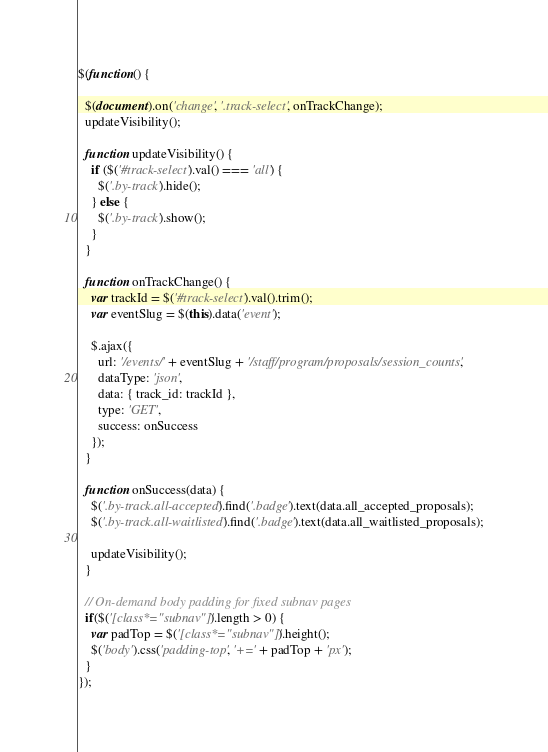<code> <loc_0><loc_0><loc_500><loc_500><_JavaScript_>$(function() {

  $(document).on('change', '.track-select', onTrackChange);
  updateVisibility();

  function updateVisibility() {
    if ($('#track-select').val() === 'all') {
      $('.by-track').hide();
    } else {
      $('.by-track').show();
    }
  }

  function onTrackChange() {
    var trackId = $('#track-select').val().trim();
    var eventSlug = $(this).data('event');

    $.ajax({
      url: '/events/' + eventSlug + '/staff/program/proposals/session_counts',
      dataType: 'json',
      data: { track_id: trackId },
      type: 'GET',
      success: onSuccess
    });
  }

  function onSuccess(data) {
    $('.by-track.all-accepted').find('.badge').text(data.all_accepted_proposals);
    $('.by-track.all-waitlisted').find('.badge').text(data.all_waitlisted_proposals);

    updateVisibility();
  }

  // On-demand body padding for fixed subnav pages
  if($('[class*="subnav"]').length > 0) {
    var padTop = $('[class*="subnav"]').height();
    $('body').css('padding-top', '+=' + padTop + 'px');
  }
});
</code> 